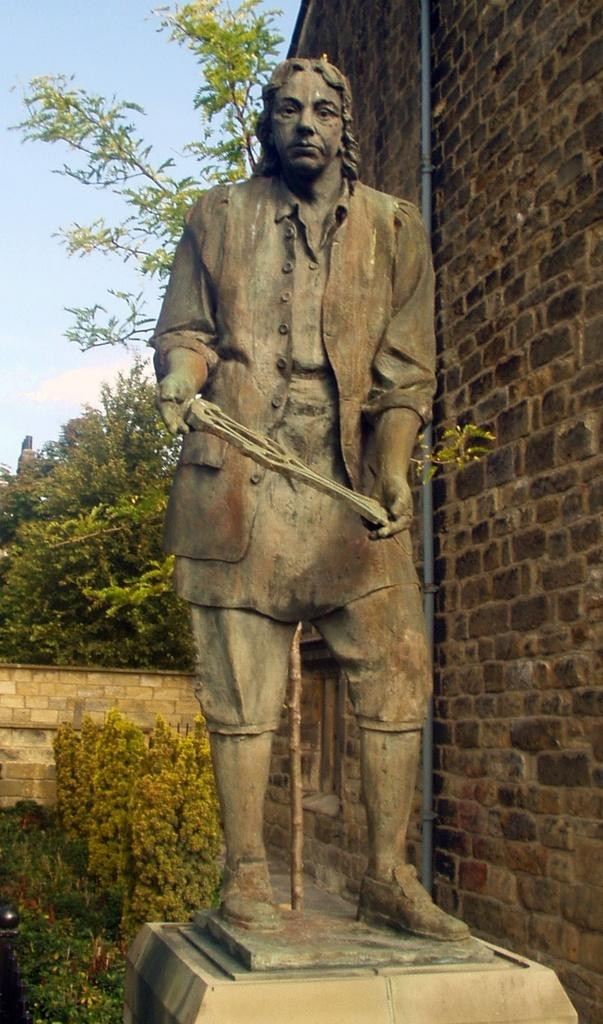What is the main subject of the image? There is a sculpture of a person in the image. What is located behind the sculpture? There are plants behind the sculpture. What type of structure can be seen in the image? There is a building visible in the image. What type of vegetation is present in the image? There are trees in the image. What can be seen in the background of the image? The sky is visible in the background of the image. What type of bell can be heard ringing in the image? There is no bell present in the image, and therefore no sound can be heard. 